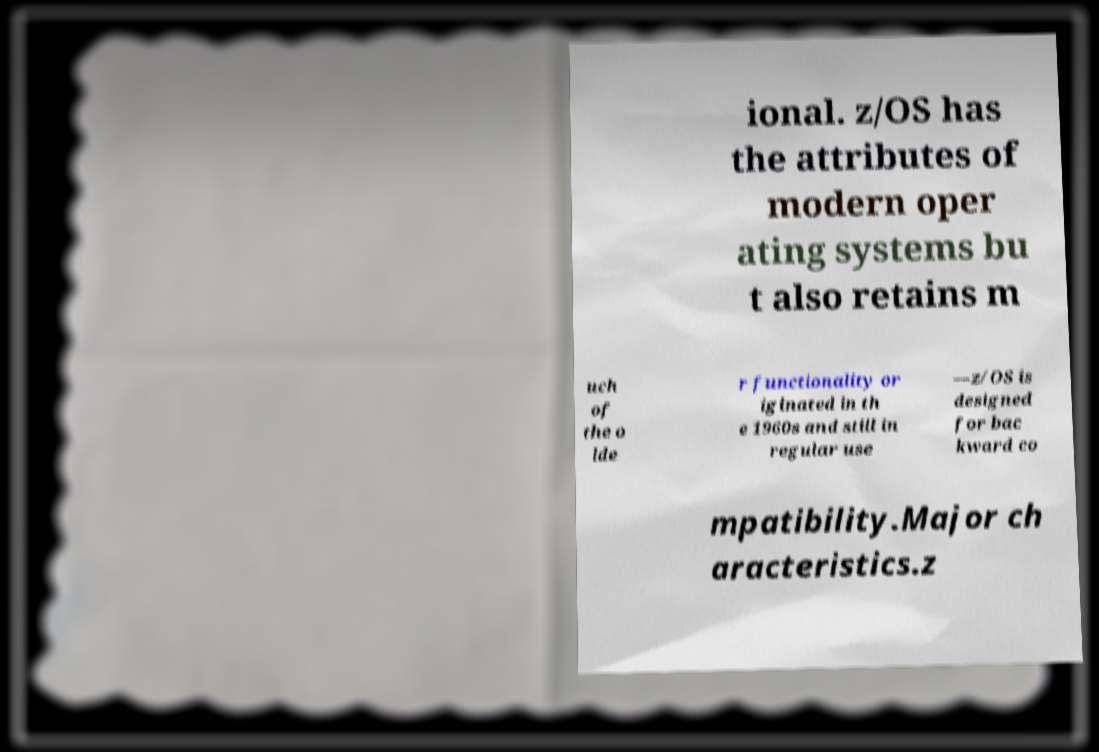There's text embedded in this image that I need extracted. Can you transcribe it verbatim? ional. z/OS has the attributes of modern oper ating systems bu t also retains m uch of the o lde r functionality or iginated in th e 1960s and still in regular use —z/OS is designed for bac kward co mpatibility.Major ch aracteristics.z 